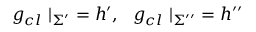<formula> <loc_0><loc_0><loc_500><loc_500>g _ { c l } | _ { \Sigma ^ { \prime } } = h ^ { \prime } , g _ { c l } | _ { \Sigma ^ { \prime \prime } } = h ^ { \prime \prime }</formula> 